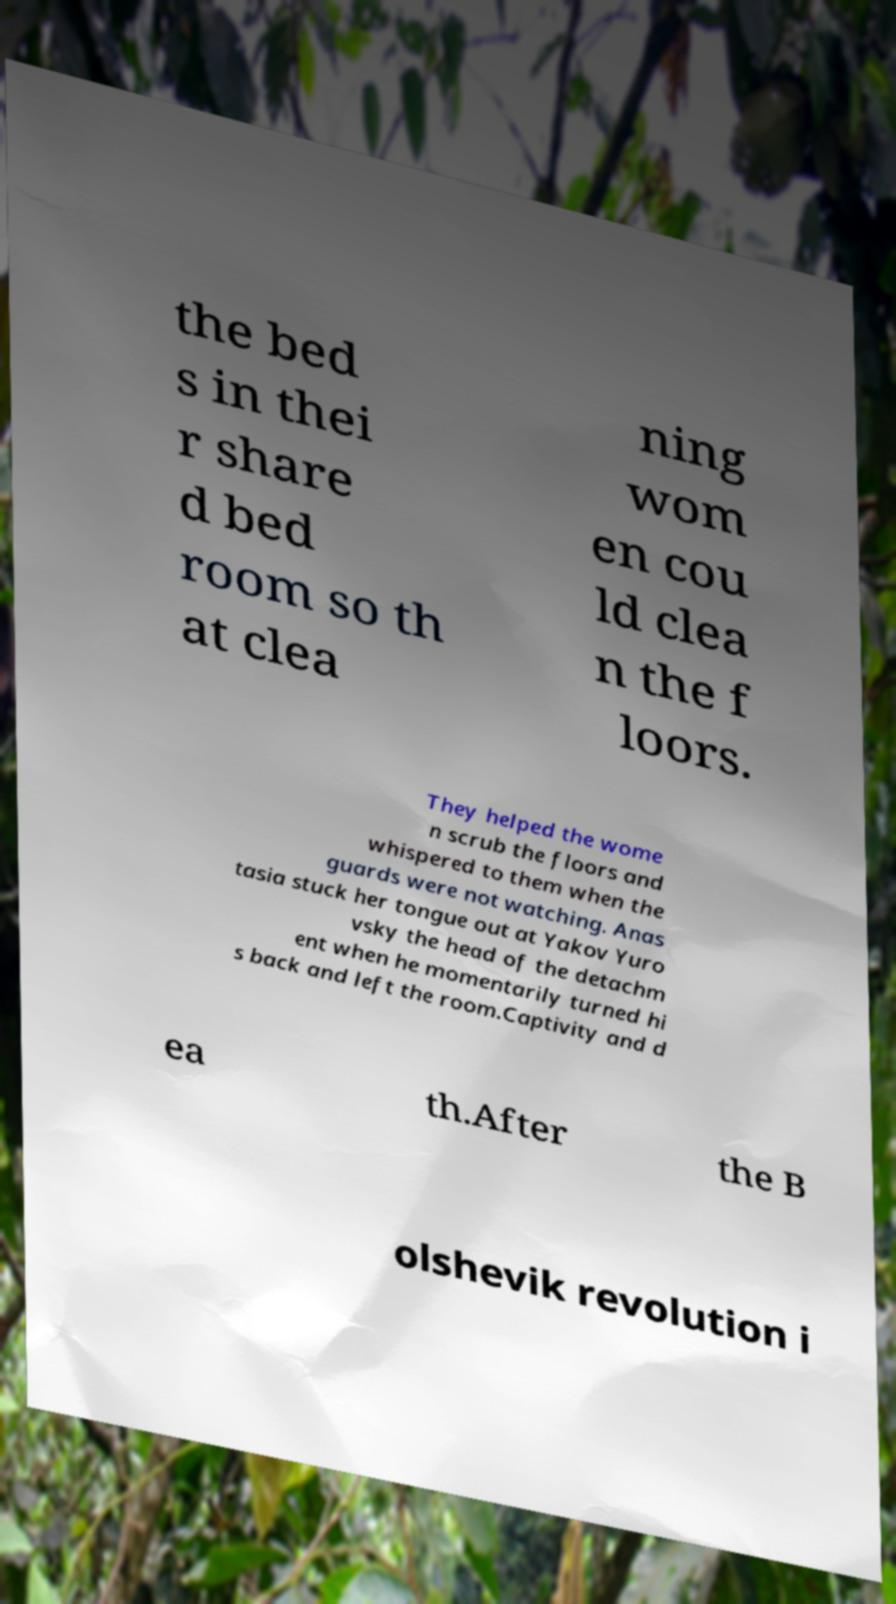Could you extract and type out the text from this image? the bed s in thei r share d bed room so th at clea ning wom en cou ld clea n the f loors. They helped the wome n scrub the floors and whispered to them when the guards were not watching. Anas tasia stuck her tongue out at Yakov Yuro vsky the head of the detachm ent when he momentarily turned hi s back and left the room.Captivity and d ea th.After the B olshevik revolution i 